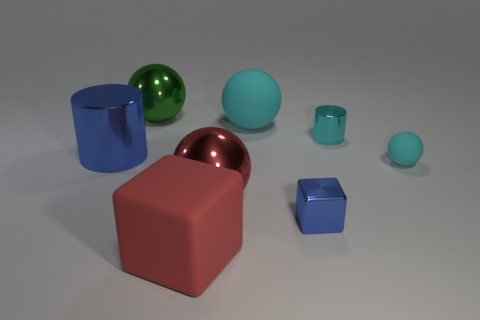What material is the cyan ball behind the shiny cylinder that is right of the ball that is left of the red metal object?
Offer a terse response. Rubber. What is the material of the large sphere that is the same color as the small rubber object?
Offer a very short reply. Rubber. How many tiny green cubes are the same material as the big blue cylinder?
Provide a succinct answer. 0. There is a shiny cylinder right of the blue cube; is it the same size as the small blue block?
Keep it short and to the point. Yes. The tiny cylinder that is the same material as the tiny blue thing is what color?
Make the answer very short. Cyan. Is there anything else that is the same size as the red shiny ball?
Offer a very short reply. Yes. What number of red metallic balls are on the left side of the matte block?
Your answer should be compact. 0. Do the metal cylinder left of the big green metal object and the shiny ball on the left side of the red block have the same color?
Offer a terse response. No. There is another matte object that is the same shape as the big cyan object; what is its color?
Provide a succinct answer. Cyan. Is there anything else that is the same shape as the green shiny thing?
Provide a short and direct response. Yes. 